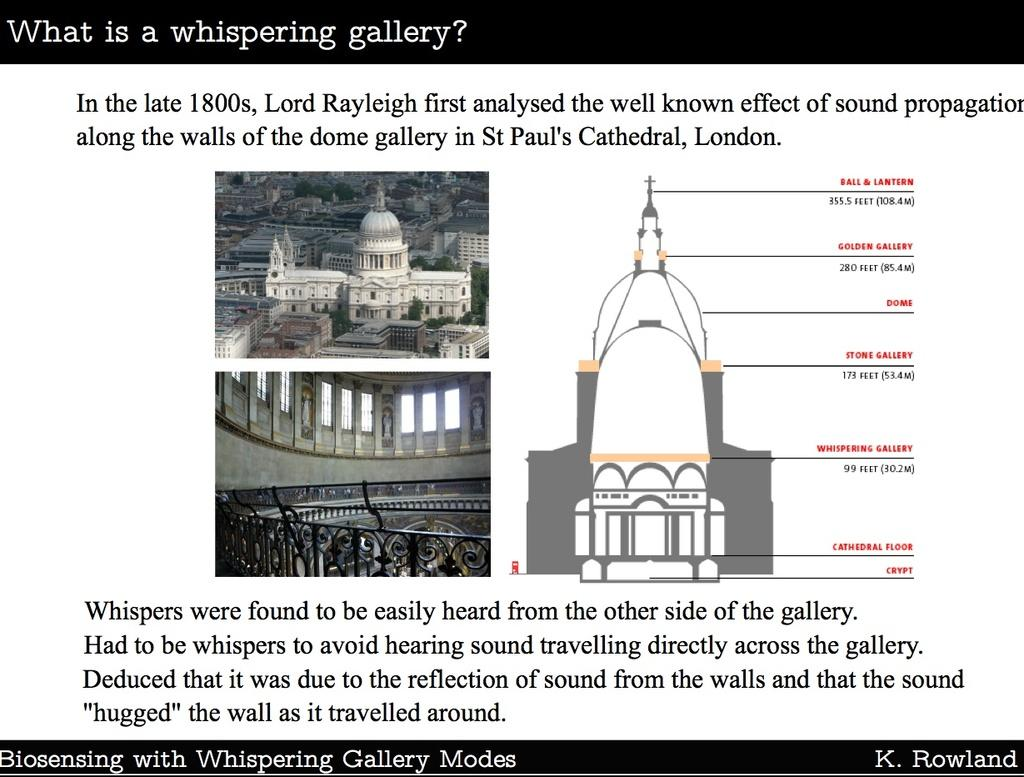<image>
Present a compact description of the photo's key features. A poster explains what a whispering gallery is. 